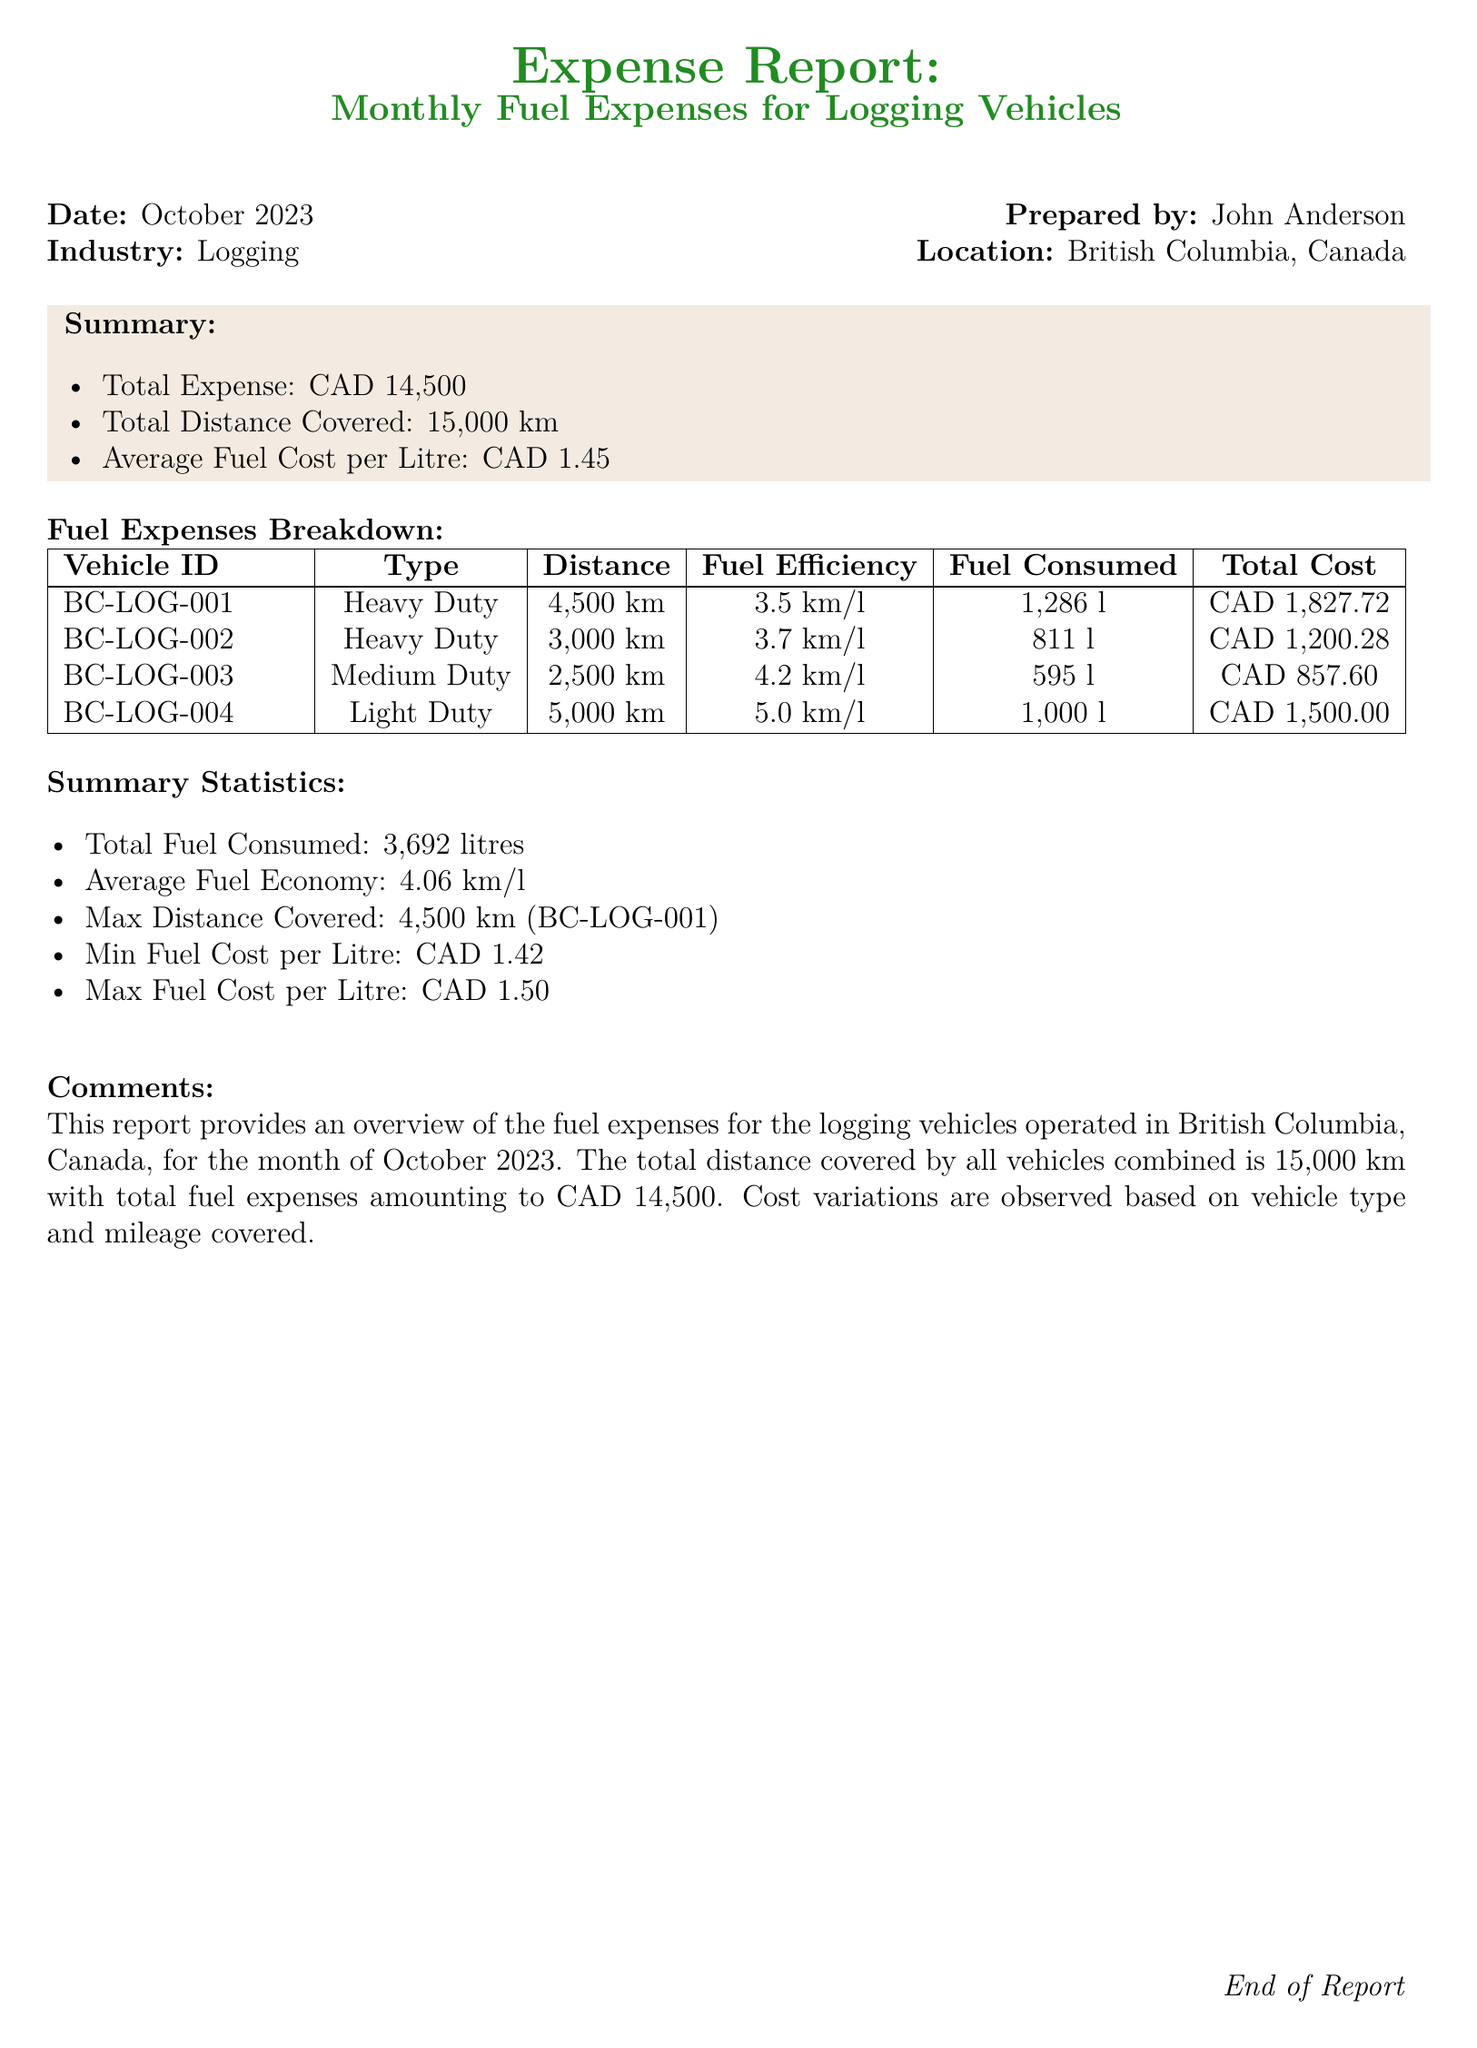What is the total expense? The total expense is summarized as CAD 14,500 in the report.
Answer: CAD 14,500 What is the average fuel cost per litre? The average fuel cost is provided as CAD 1.45 in the summary.
Answer: CAD 1.45 How much fuel was consumed by vehicle BC-LOG-003? The fuel consumed for vehicle BC-LOG-003 is listed as 595 litres.
Answer: 595 l What is the distance covered by BC-LOG-004? The total distance covered by vehicle BC-LOG-004 is mentioned as 5,000 km.
Answer: 5,000 km Which vehicle covered the maximum distance? The report states that vehicle BC-LOG-001 covered the maximum distance of 4,500 km.
Answer: BC-LOG-001 What is the total fuel consumed? The total fuel consumed is summarized as 3,692 litres in the statistics section.
Answer: 3,692 litres What was the maximum fuel cost per litre? The maximum fuel cost per litre is indicated as CAD 1.50 in the summary statistics.
Answer: CAD 1.50 How many vehicles are listed in the fuel expenses breakdown? The breakdown includes four vehicles as detailed in the table.
Answer: 4 What is the prepared date of the report? The date of the report is indicated as October 2023.
Answer: October 2023 